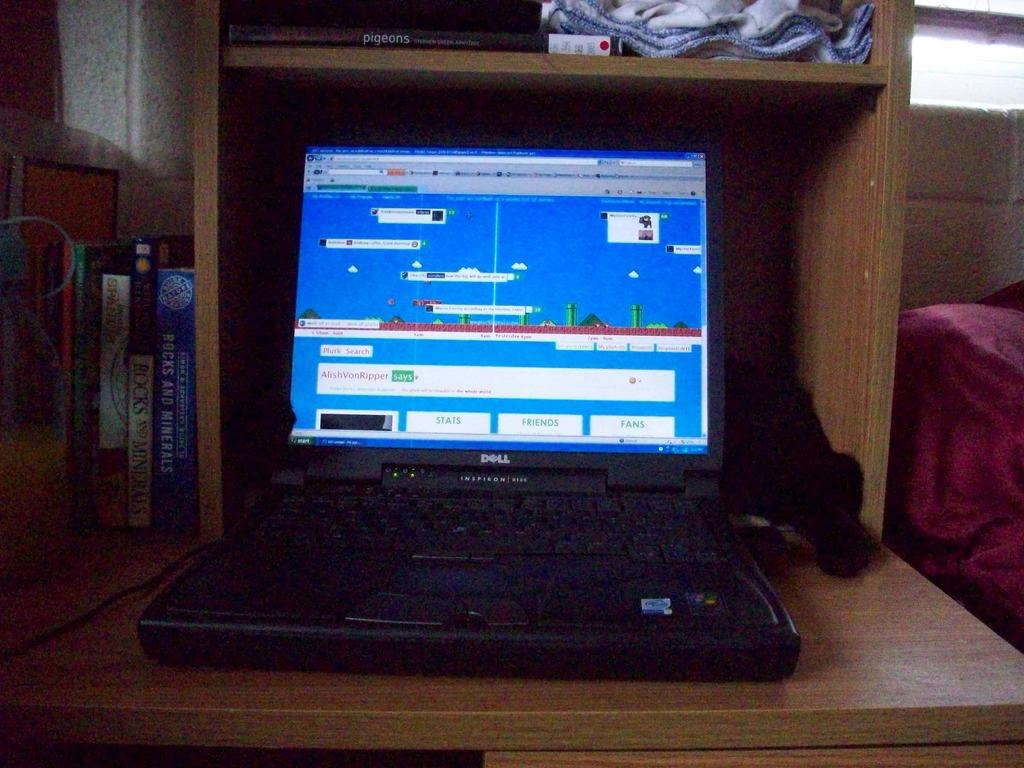<image>
Describe the image concisely. Dell Inspirion Laptop with different images on the main screen. 